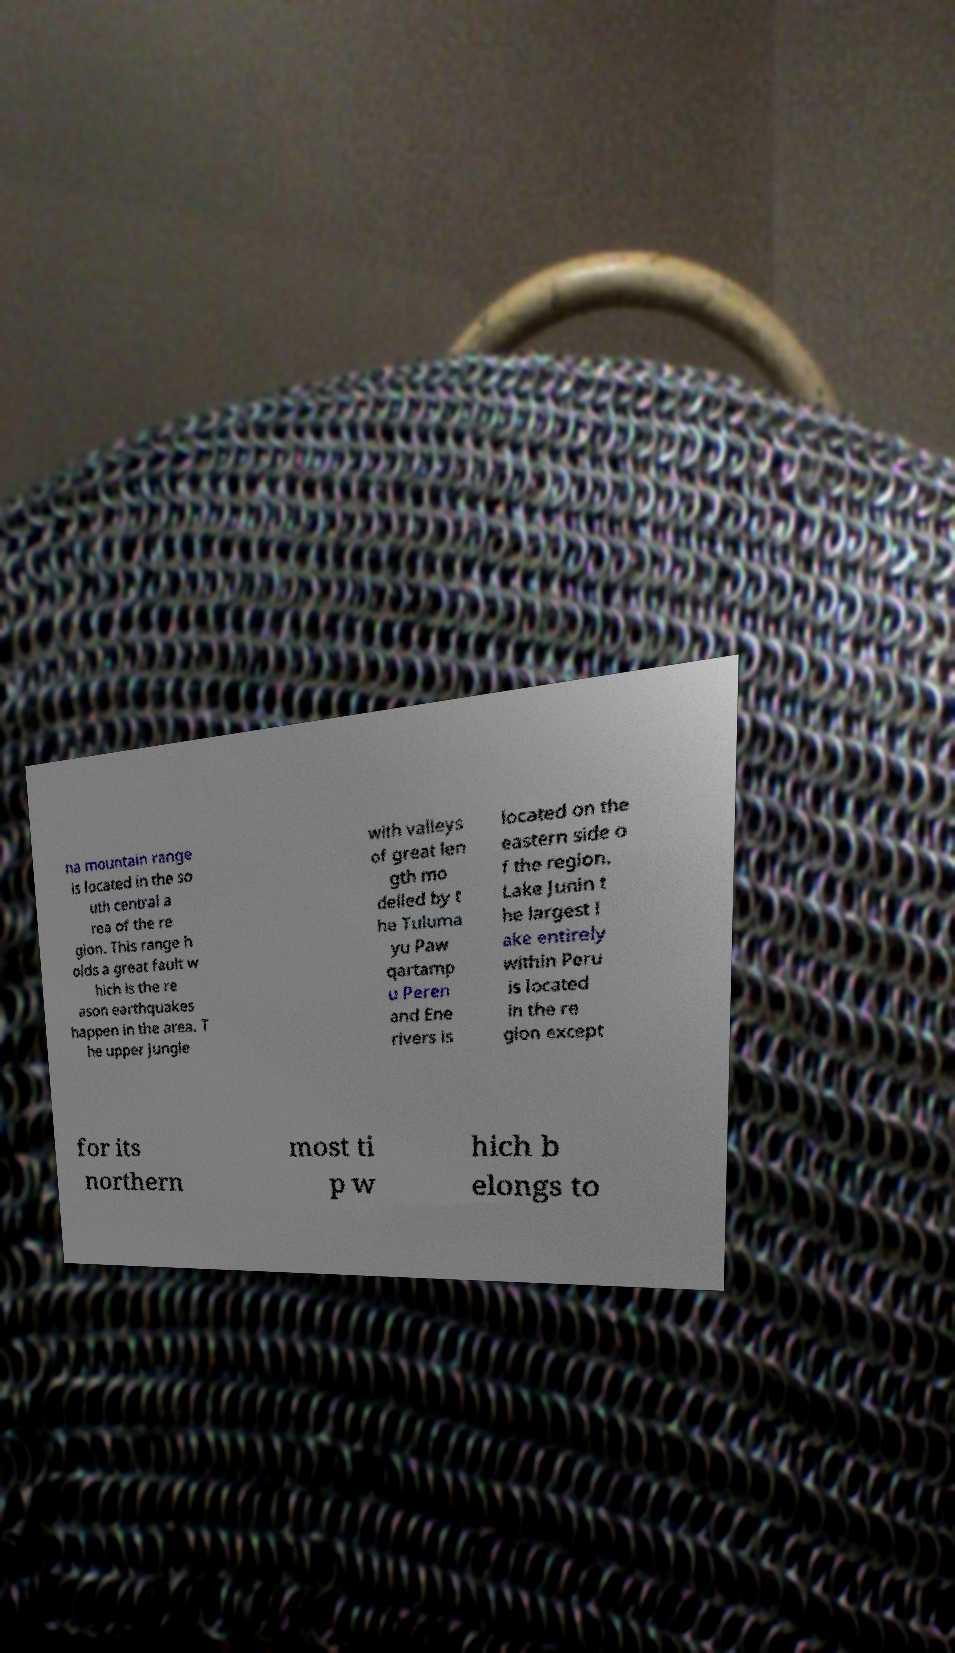Please identify and transcribe the text found in this image. na mountain range is located in the so uth central a rea of the re gion. This range h olds a great fault w hich is the re ason earthquakes happen in the area. T he upper jungle with valleys of great len gth mo delled by t he Tuluma yu Paw qartamp u Peren and Ene rivers is located on the eastern side o f the region. Lake Junin t he largest l ake entirely within Peru is located in the re gion except for its northern most ti p w hich b elongs to 